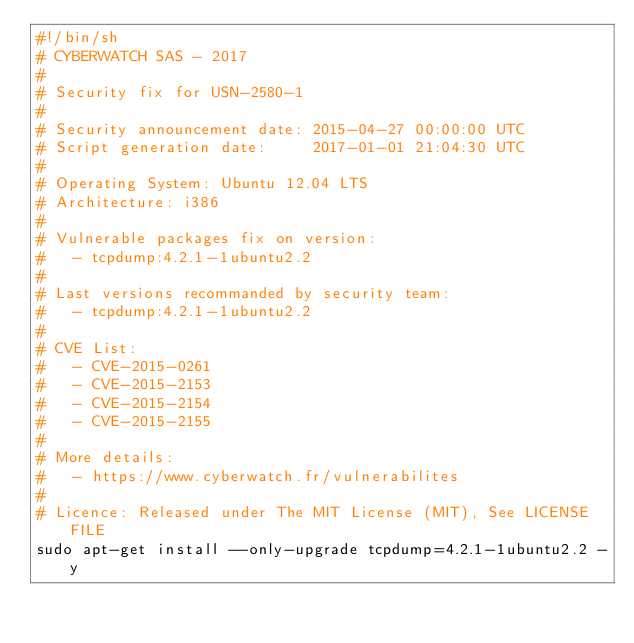Convert code to text. <code><loc_0><loc_0><loc_500><loc_500><_Bash_>#!/bin/sh
# CYBERWATCH SAS - 2017
#
# Security fix for USN-2580-1
#
# Security announcement date: 2015-04-27 00:00:00 UTC
# Script generation date:     2017-01-01 21:04:30 UTC
#
# Operating System: Ubuntu 12.04 LTS
# Architecture: i386
#
# Vulnerable packages fix on version:
#   - tcpdump:4.2.1-1ubuntu2.2
#
# Last versions recommanded by security team:
#   - tcpdump:4.2.1-1ubuntu2.2
#
# CVE List:
#   - CVE-2015-0261
#   - CVE-2015-2153
#   - CVE-2015-2154
#   - CVE-2015-2155
#
# More details:
#   - https://www.cyberwatch.fr/vulnerabilites
#
# Licence: Released under The MIT License (MIT), See LICENSE FILE
sudo apt-get install --only-upgrade tcpdump=4.2.1-1ubuntu2.2 -y
</code> 